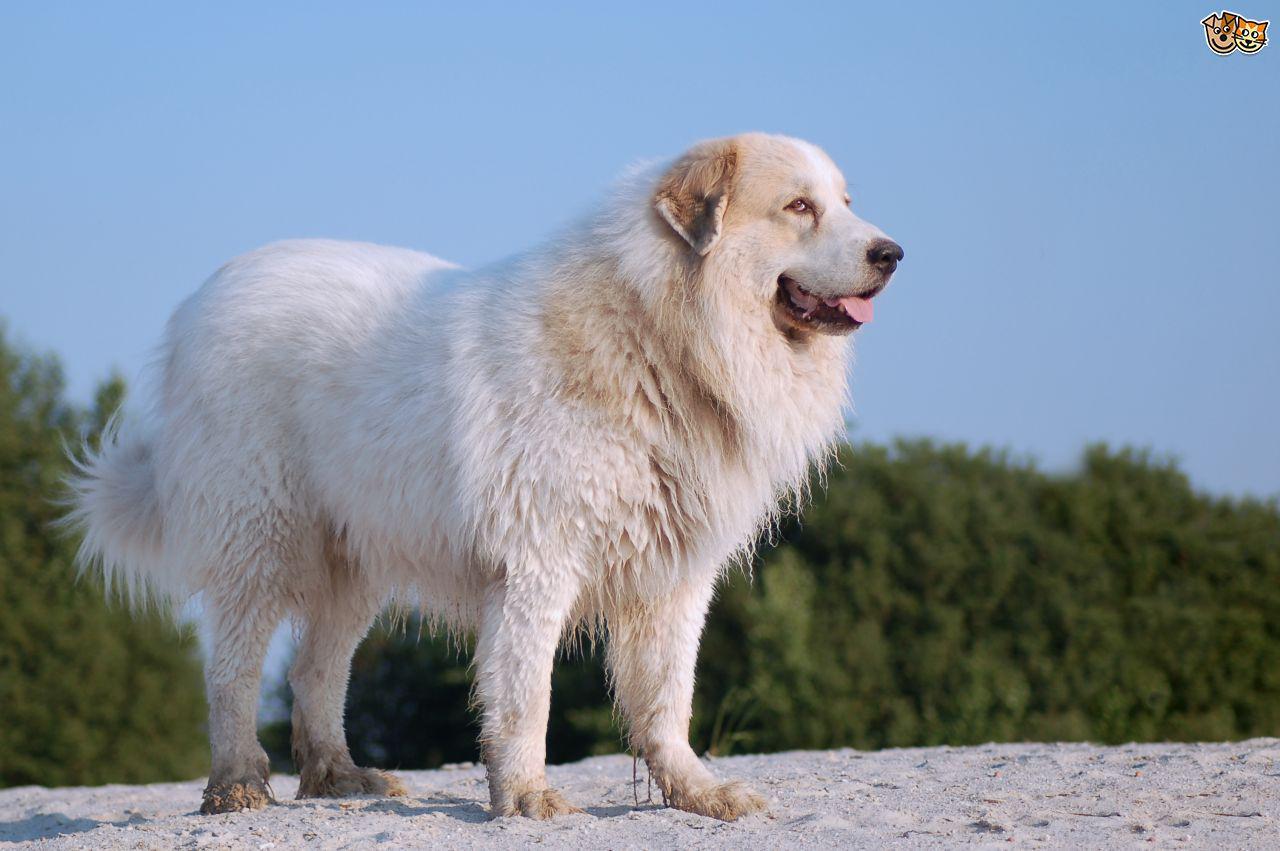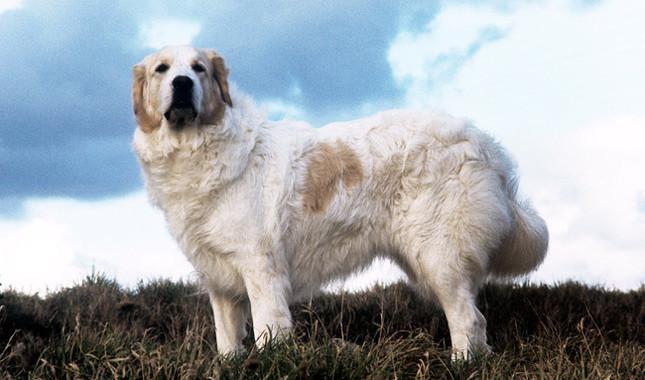The first image is the image on the left, the second image is the image on the right. Analyze the images presented: Is the assertion "All images show one dog that is standing." valid? Answer yes or no. Yes. The first image is the image on the left, the second image is the image on the right. For the images shown, is this caption "All images show one adult dog standing still outdoors." true? Answer yes or no. Yes. 